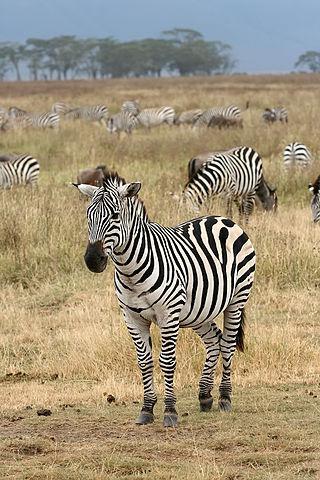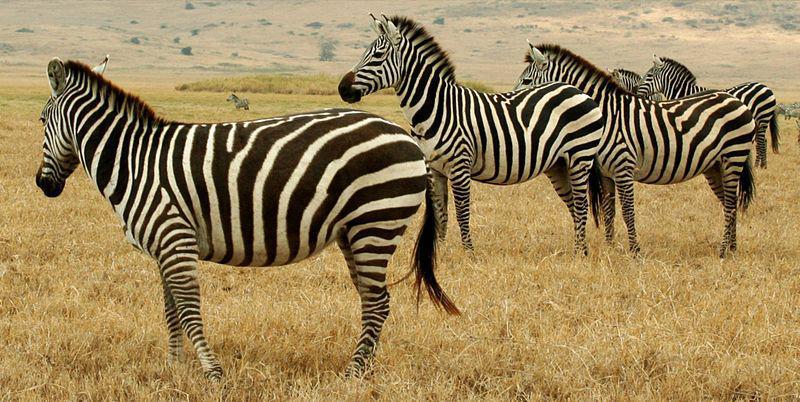The first image is the image on the left, the second image is the image on the right. For the images shown, is this caption "Here we have exactly three zebras." true? Answer yes or no. No. The first image is the image on the left, the second image is the image on the right. Examine the images to the left and right. Is the description "There is a single zebra in one image." accurate? Answer yes or no. No. 